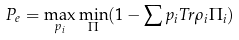Convert formula to latex. <formula><loc_0><loc_0><loc_500><loc_500>P _ { e } = \max _ { p _ { i } } \min _ { \Pi } ( 1 - \sum p _ { i } T r \rho _ { i } \Pi _ { i } )</formula> 